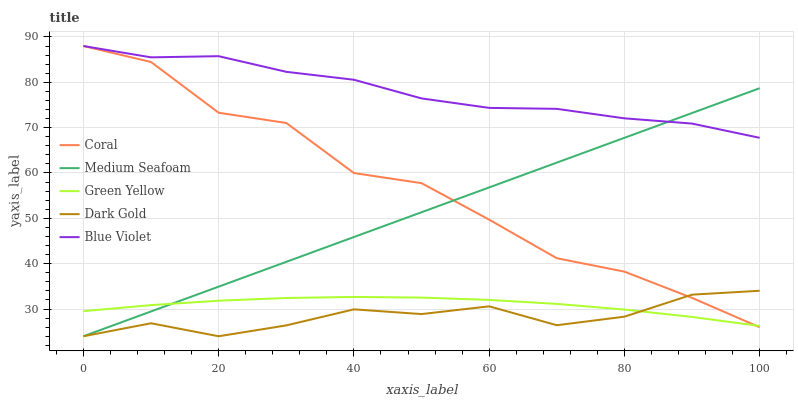Does Dark Gold have the minimum area under the curve?
Answer yes or no. Yes. Does Blue Violet have the maximum area under the curve?
Answer yes or no. Yes. Does Green Yellow have the minimum area under the curve?
Answer yes or no. No. Does Green Yellow have the maximum area under the curve?
Answer yes or no. No. Is Medium Seafoam the smoothest?
Answer yes or no. Yes. Is Coral the roughest?
Answer yes or no. Yes. Is Green Yellow the smoothest?
Answer yes or no. No. Is Green Yellow the roughest?
Answer yes or no. No. Does Green Yellow have the lowest value?
Answer yes or no. No. Does Medium Seafoam have the highest value?
Answer yes or no. No. Is Dark Gold less than Blue Violet?
Answer yes or no. Yes. Is Blue Violet greater than Dark Gold?
Answer yes or no. Yes. Does Dark Gold intersect Blue Violet?
Answer yes or no. No. 